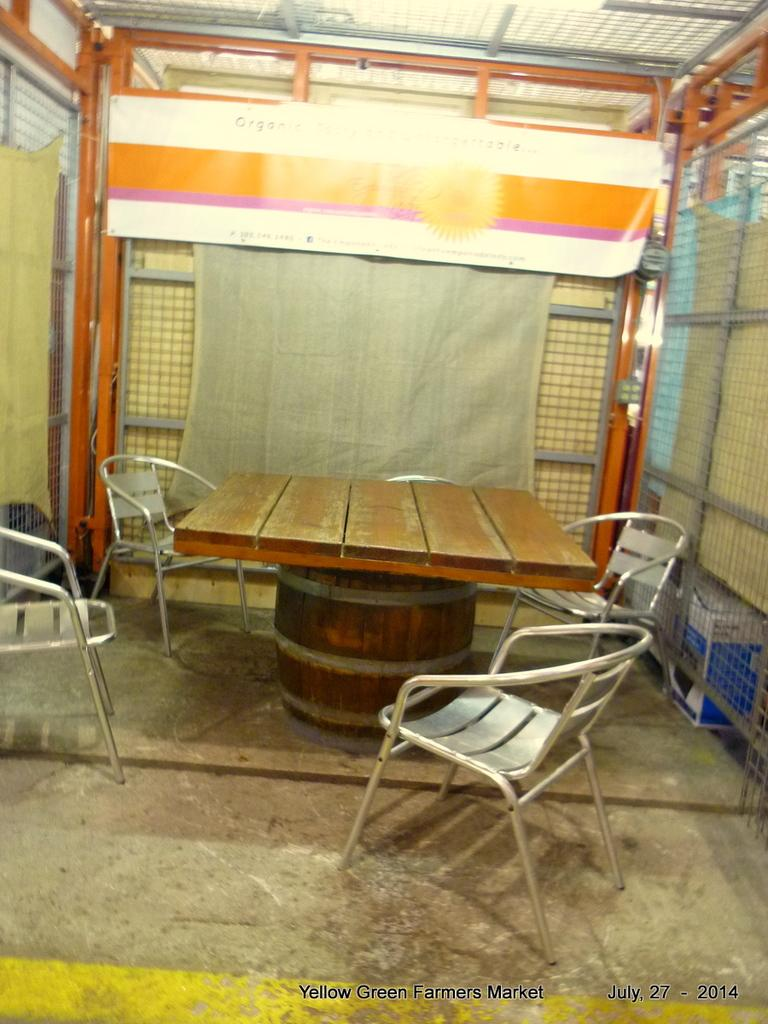How many chairs are in the image? There are four metal chairs in the image. How are the chairs arranged in relation to each other? The chairs are arranged around a wooden table. What can be seen in the background of the image? There is a fence visible in the background of the image. How many gallons of milk are being produced by the cattle in the image? There are no cattle or milk production visible in the image; it features four metal chairs arranged around a wooden table with a fence in the background. Can you describe the lizards crawling on the chairs in the image? There are no lizards present in the image; it only features four metal chairs, a wooden table, and a fence in the background. 